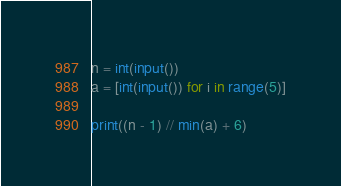Convert code to text. <code><loc_0><loc_0><loc_500><loc_500><_Python_>n = int(input())
a = [int(input()) for i in range(5)]

print((n - 1) // min(a) + 6)</code> 